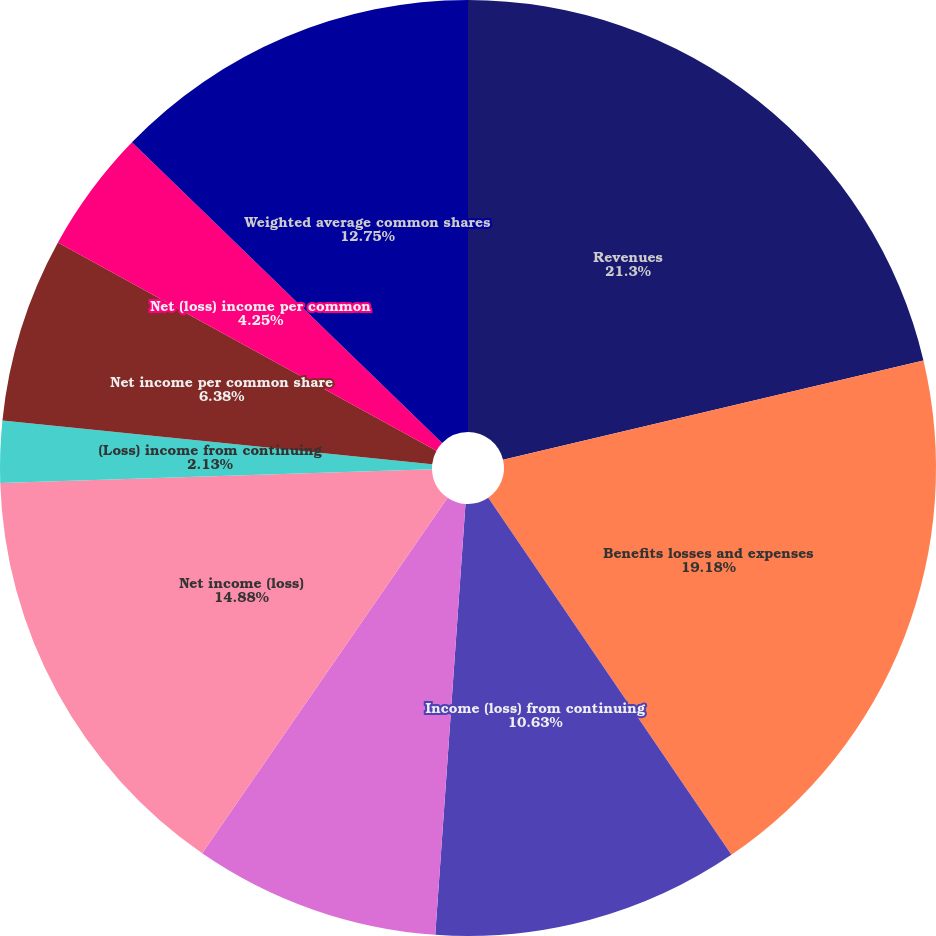Convert chart. <chart><loc_0><loc_0><loc_500><loc_500><pie_chart><fcel>Revenues<fcel>Benefits losses and expenses<fcel>Income (loss) from continuing<fcel>Income from discontinued<fcel>Net income (loss)<fcel>(Loss) income from continuing<fcel>(Loss) income from<fcel>Net income per common share<fcel>Net (loss) income per common<fcel>Weighted average common shares<nl><fcel>21.31%<fcel>19.18%<fcel>10.63%<fcel>8.5%<fcel>14.88%<fcel>2.13%<fcel>0.0%<fcel>6.38%<fcel>4.25%<fcel>12.75%<nl></chart> 